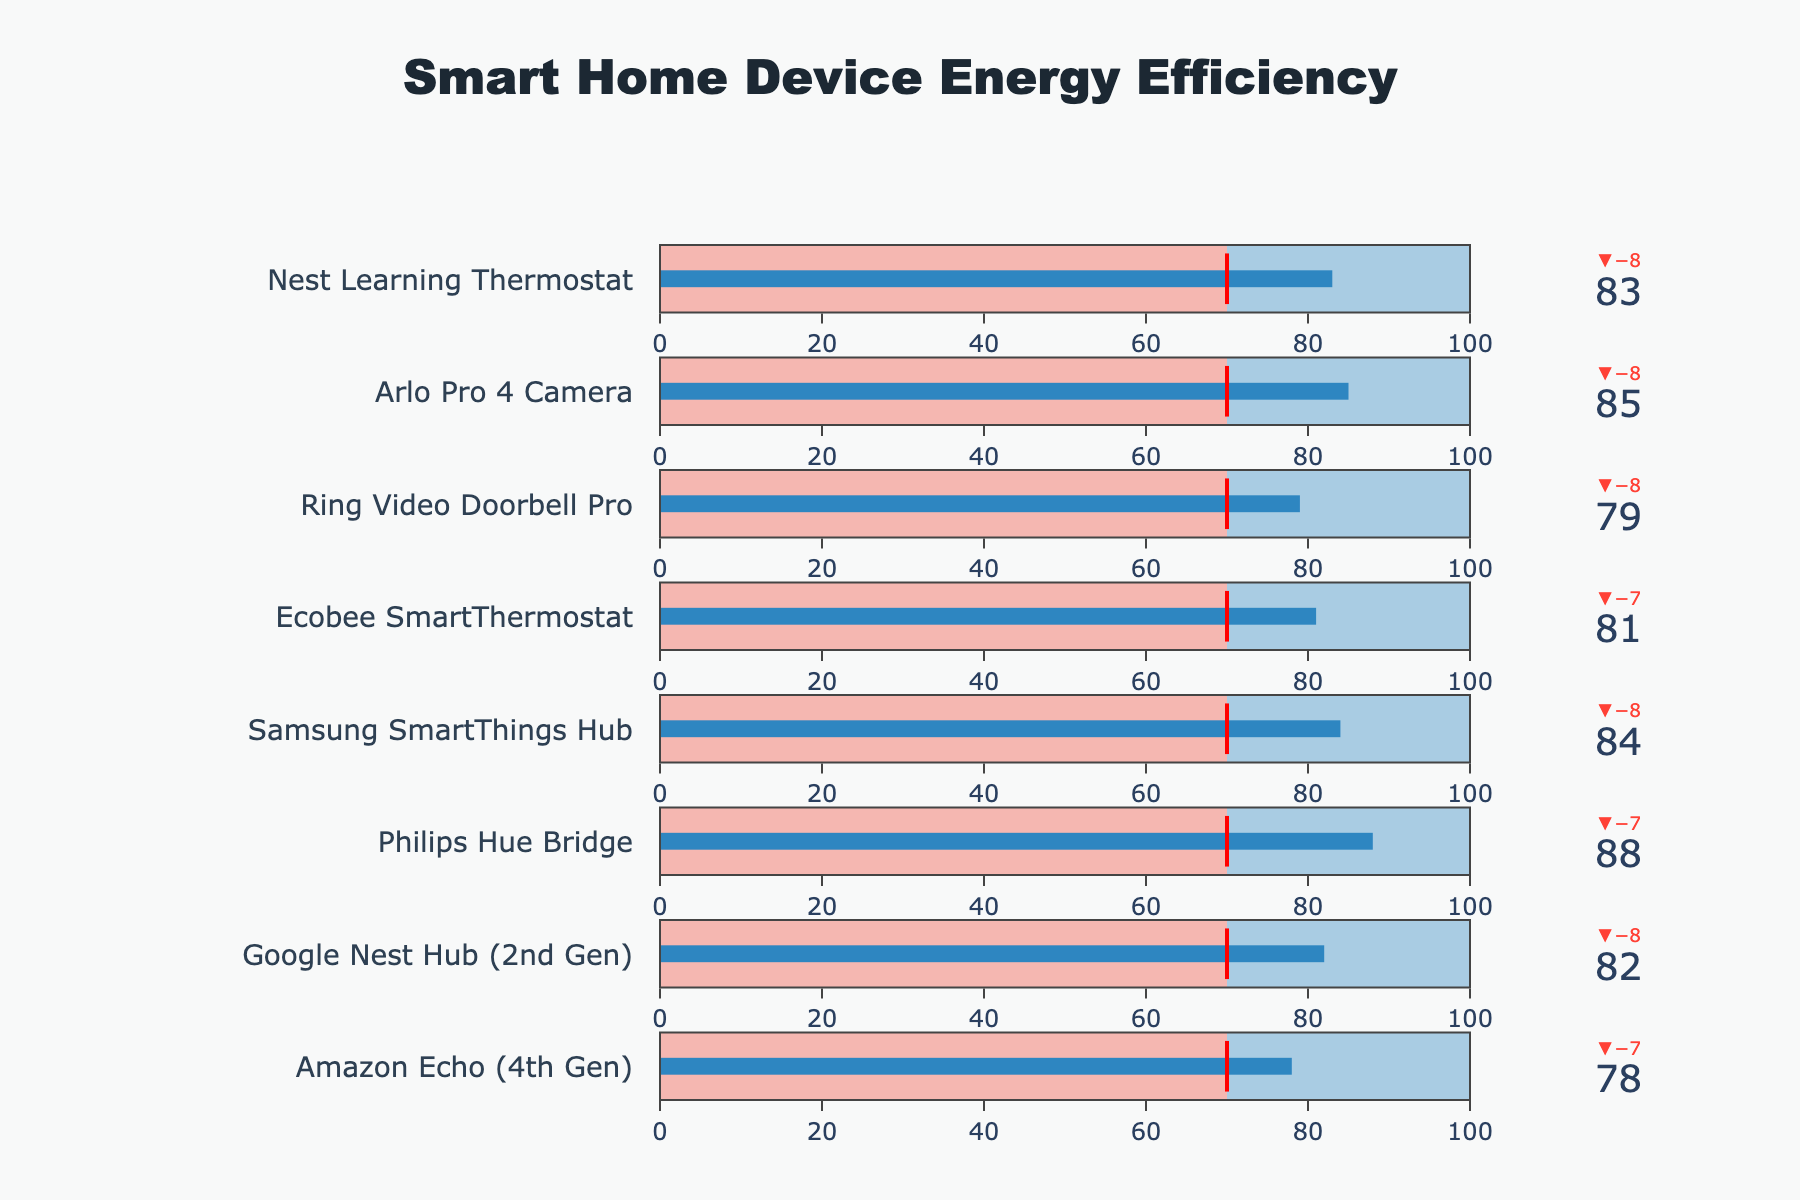What is the title of the figure? The figure's title is located at the top center and provides an immediate summary of the chart. It is specifically styled with different font properties, making it easily noticeable.
Answer: Smart Home Device Energy Efficiency How many devices are compared in the figure? Each device is represented by a separate bullet chart trace. By counting the individual bullet charts, the total number of devices can be determined.
Answer: Eight Which device has the largest difference between claimed and actual efficiency? The difference is the absolute value of the delta between claimed and actual efficiency. By inspecting the deltas, the device with the largest absolute difference can be found.
Answer: Philips Hue Bridge Which devices have an actual efficiency lower than the industry average? The industry average threshold is marked by a red line. Devices with actual efficiency values below this line are the ones we're looking for.
Answer: None What's the average of the actual efficiency scores of all devices? To find the average, sum up the actual efficiency scores of all devices and divide by the number of devices (8). This involves simple arithmetic operations.
Answer: (78 + 82 + 88 + 84 + 81 + 79 + 85 + 83) / 8 = 82.5 How does the actual efficiency of the Google Nest Hub (2nd Gen) compare to the industry average? The actual efficiency value for the Google Nest Hub (2nd Gen) is compared directly to the industry average of 70. Visual elements like the position of the efficiency bar relative to the threshold can guide the comparison.
Answer: Above Which device has the highest actual efficiency score? By examining the 'Actual Efficiency' gauge readings for each device, the device with the highest value can be identified.
Answer: Philips Hue Bridge What is the difference between the highest and the lowest actual efficiency scores? Identify the highest and lowest actual efficiency values, then subtract the lowest from the highest. This requires identifying extremum values and performing subtraction.
Answer: 88 - 78 = 10 Which device comes closest to meeting its claimed efficiency? Assess the delta values shown on top of each bullet chart. The smallest delta (closest to zero) indicates the closest match to the claimed efficiency.
Answer: Philips Hue Bridge How does the actual efficiency of the Ring Video Doorbell Pro compare to the Nest Learning Thermostat? Compare the actual efficiency values of both devices side-by-side to determine which is higher or if they are equal.
Answer: Ring Video Doorbell Pro is lower 